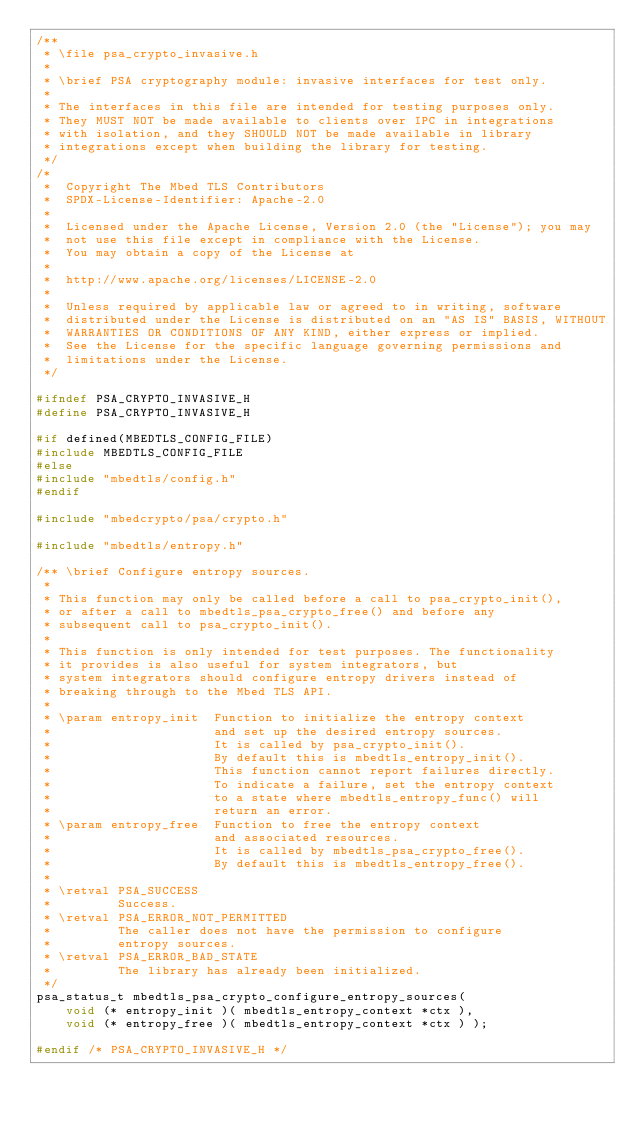<code> <loc_0><loc_0><loc_500><loc_500><_C_>/**
 * \file psa_crypto_invasive.h
 *
 * \brief PSA cryptography module: invasive interfaces for test only.
 *
 * The interfaces in this file are intended for testing purposes only.
 * They MUST NOT be made available to clients over IPC in integrations
 * with isolation, and they SHOULD NOT be made available in library
 * integrations except when building the library for testing.
 */
/*
 *  Copyright The Mbed TLS Contributors
 *  SPDX-License-Identifier: Apache-2.0
 *
 *  Licensed under the Apache License, Version 2.0 (the "License"); you may
 *  not use this file except in compliance with the License.
 *  You may obtain a copy of the License at
 *
 *  http://www.apache.org/licenses/LICENSE-2.0
 *
 *  Unless required by applicable law or agreed to in writing, software
 *  distributed under the License is distributed on an "AS IS" BASIS, WITHOUT
 *  WARRANTIES OR CONDITIONS OF ANY KIND, either express or implied.
 *  See the License for the specific language governing permissions and
 *  limitations under the License.
 */

#ifndef PSA_CRYPTO_INVASIVE_H
#define PSA_CRYPTO_INVASIVE_H

#if defined(MBEDTLS_CONFIG_FILE)
#include MBEDTLS_CONFIG_FILE
#else
#include "mbedtls/config.h"
#endif

#include "mbedcrypto/psa/crypto.h"

#include "mbedtls/entropy.h"

/** \brief Configure entropy sources.
 *
 * This function may only be called before a call to psa_crypto_init(),
 * or after a call to mbedtls_psa_crypto_free() and before any
 * subsequent call to psa_crypto_init().
 *
 * This function is only intended for test purposes. The functionality
 * it provides is also useful for system integrators, but
 * system integrators should configure entropy drivers instead of
 * breaking through to the Mbed TLS API.
 *
 * \param entropy_init  Function to initialize the entropy context
 *                      and set up the desired entropy sources.
 *                      It is called by psa_crypto_init().
 *                      By default this is mbedtls_entropy_init().
 *                      This function cannot report failures directly.
 *                      To indicate a failure, set the entropy context
 *                      to a state where mbedtls_entropy_func() will
 *                      return an error.
 * \param entropy_free  Function to free the entropy context
 *                      and associated resources.
 *                      It is called by mbedtls_psa_crypto_free().
 *                      By default this is mbedtls_entropy_free().
 *
 * \retval PSA_SUCCESS
 *         Success.
 * \retval PSA_ERROR_NOT_PERMITTED
 *         The caller does not have the permission to configure
 *         entropy sources.
 * \retval PSA_ERROR_BAD_STATE
 *         The library has already been initialized.
 */
psa_status_t mbedtls_psa_crypto_configure_entropy_sources(
    void (* entropy_init )( mbedtls_entropy_context *ctx ),
    void (* entropy_free )( mbedtls_entropy_context *ctx ) );

#endif /* PSA_CRYPTO_INVASIVE_H */
</code> 